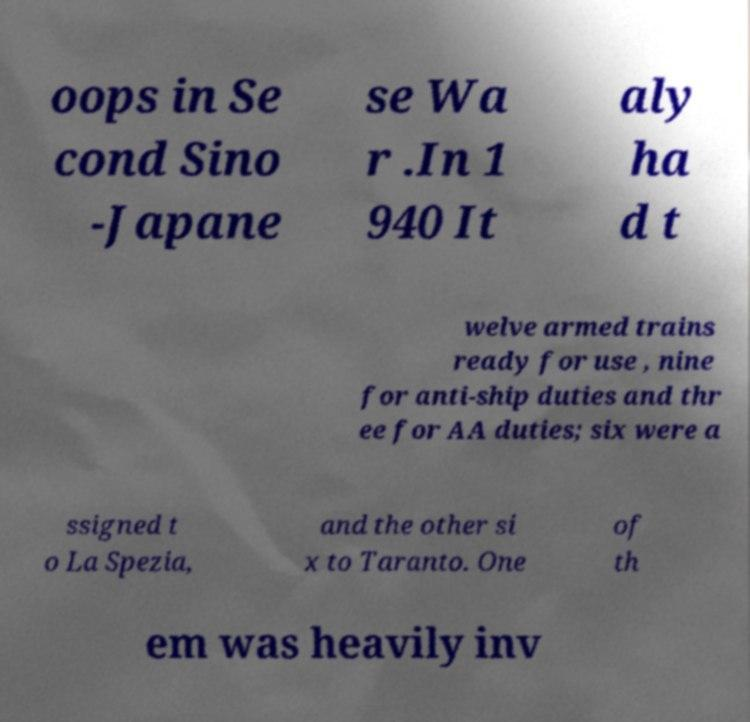There's text embedded in this image that I need extracted. Can you transcribe it verbatim? oops in Se cond Sino -Japane se Wa r .In 1 940 It aly ha d t welve armed trains ready for use , nine for anti-ship duties and thr ee for AA duties; six were a ssigned t o La Spezia, and the other si x to Taranto. One of th em was heavily inv 